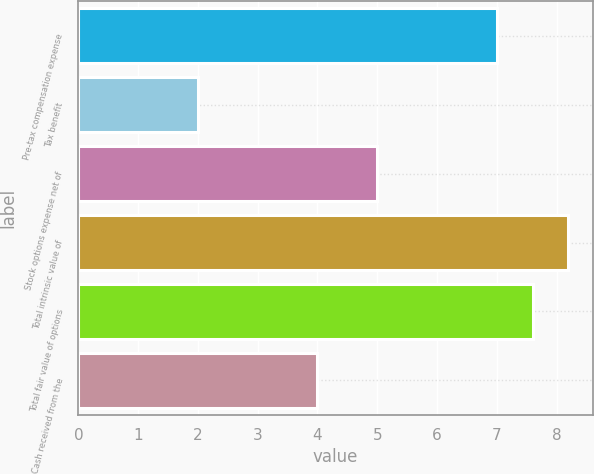Convert chart. <chart><loc_0><loc_0><loc_500><loc_500><bar_chart><fcel>Pre-tax compensation expense<fcel>Tax benefit<fcel>Stock options expense net of<fcel>Total intrinsic value of<fcel>Total fair value of options<fcel>Cash received from the<nl><fcel>7<fcel>2<fcel>5<fcel>8.2<fcel>7.6<fcel>4<nl></chart> 